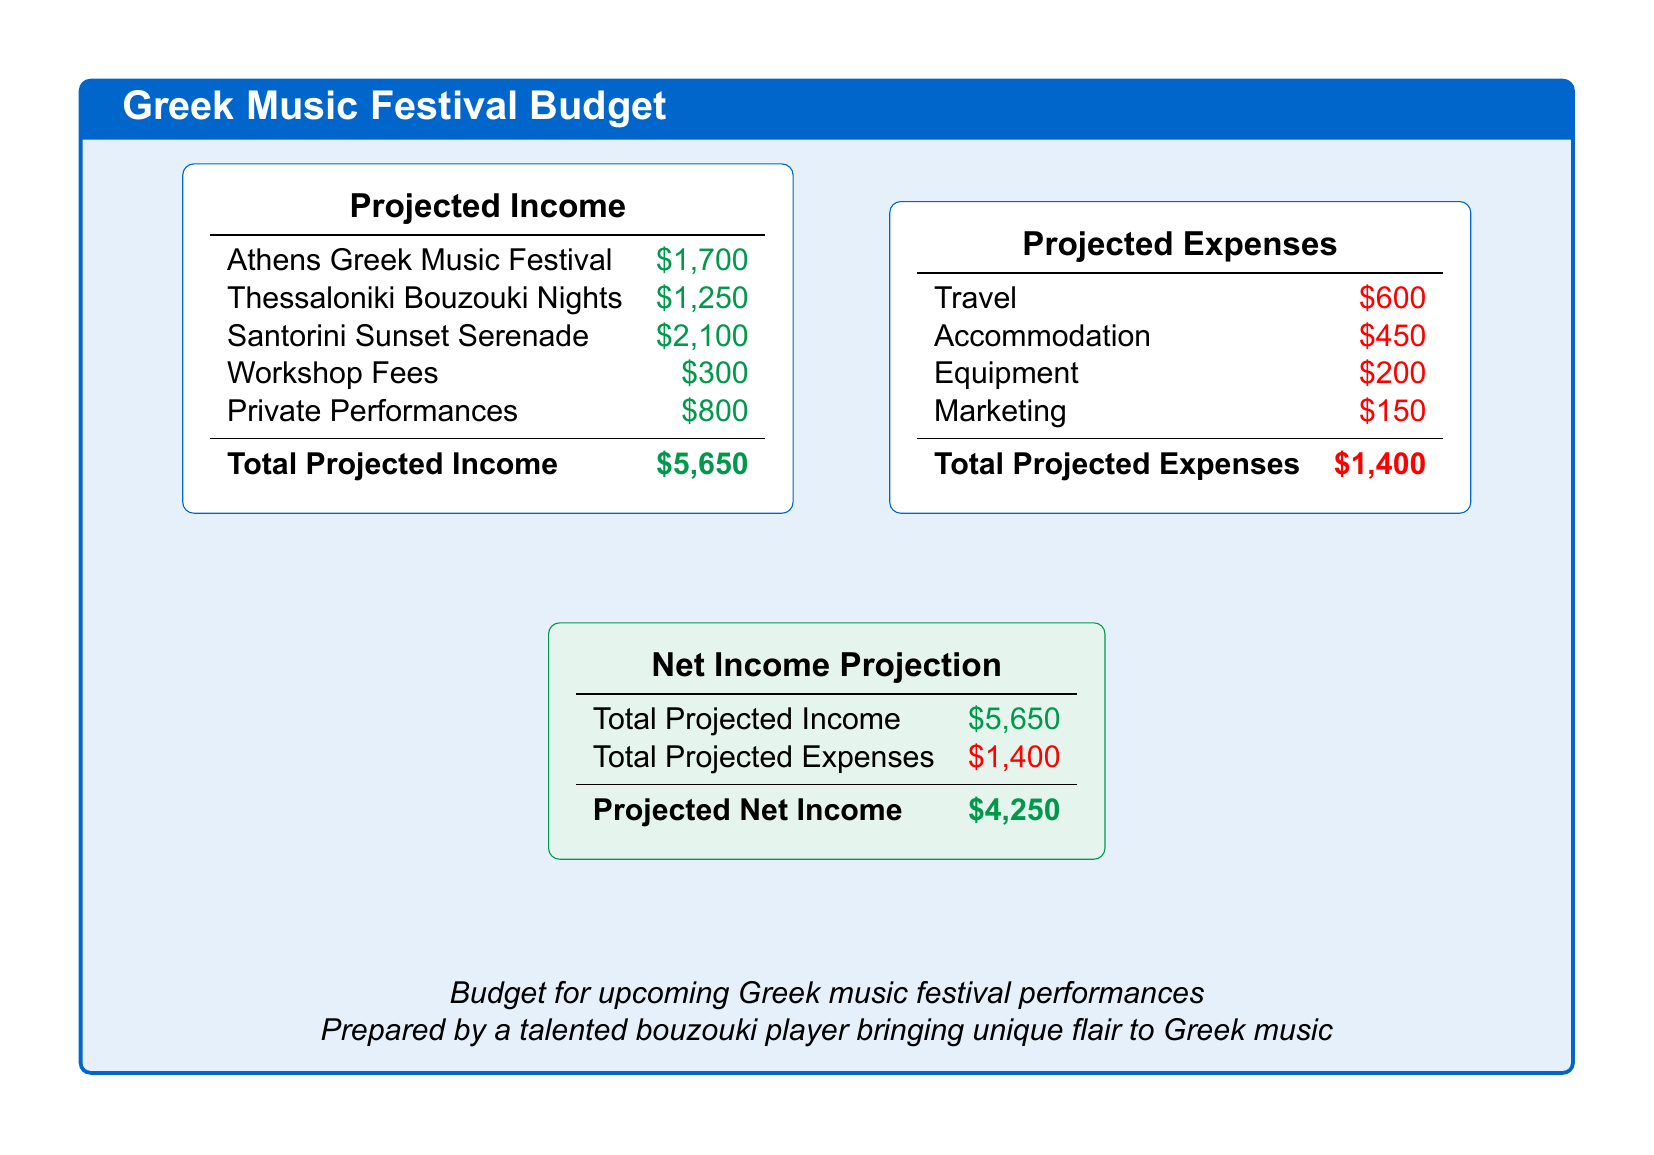What is the total projected income? The total projected income is calculated as the sum of all income sources listed: $1,700 + $1,250 + $2,100 + $300 + $800 = $5,650.
Answer: $5,650 What is the income from the Santorini Sunset Serenade? The income from the Santorini Sunset Serenade performance is listed specifically in the document.
Answer: $2,100 How much are the workshop fees? The workshop fees are mentioned as a separate source of income in the document.
Answer: $300 What are the total projected expenses? The total projected expenses are calculated by summing all expense items listed: $600 + $450 + $200 + $150 = $1,400.
Answer: $1,400 What is the projected net income? The projected net income is found by subtracting total projected expenses from total projected income: $5,650 - $1,400 = $4,250.
Answer: $4,250 Which item has the highest income projection? The document provides income projections for several events, of which one has the highest value.
Answer: Santorini Sunset Serenade What is the total budget’s focus? The document outlines the financial aspects related to performances of a specific type of music.
Answer: Greek music festival performances What is the name of the person who prepared the budget? The document attributes the budget's preparation to a specific role, highlighting its artistic focus.
Answer: A talented bouzouki player How much is allocated for marketing expenses? The marketing expense is detailed in the budget under expenses.
Answer: $150 Which city is associated with the second-highest projected income? The cities listed in the income section correspond to specific performance events.
Answer: Thessaloniki 